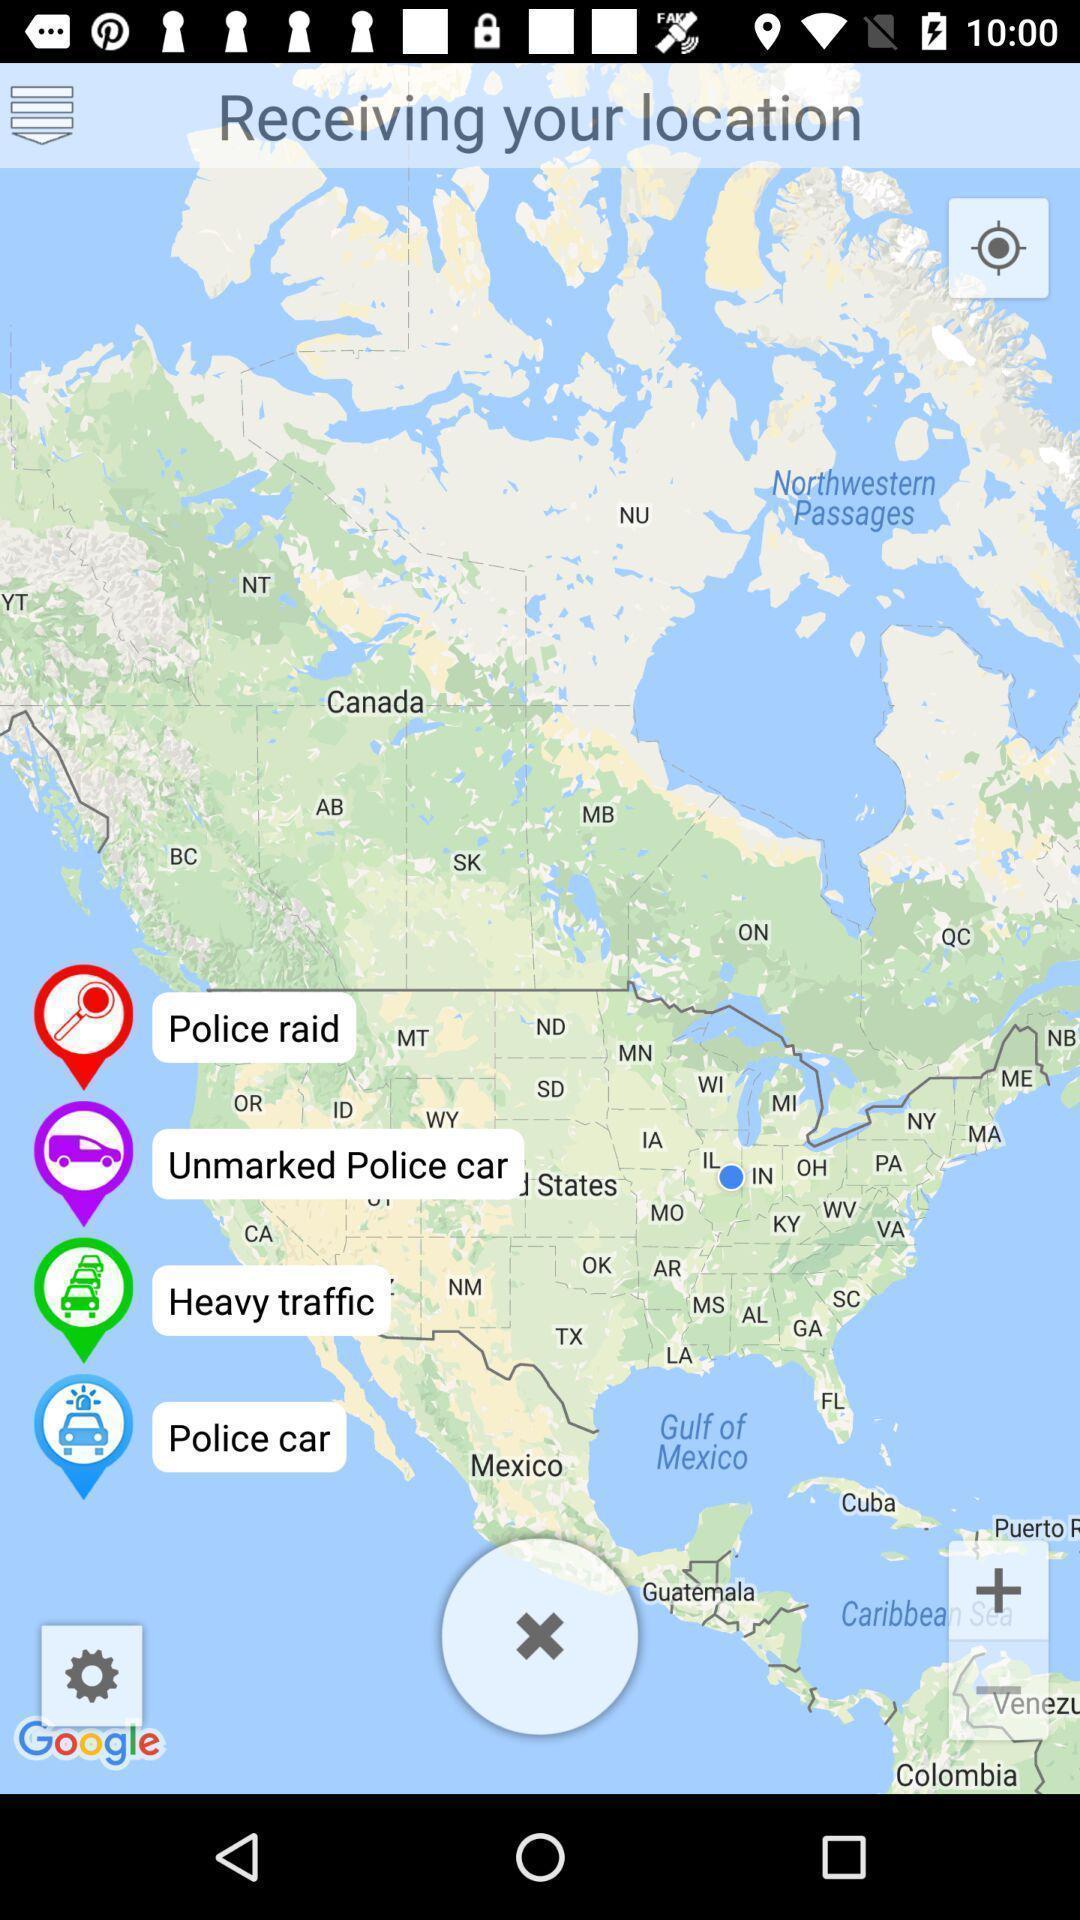Tell me about the visual elements in this screen capture. Screen page displaying map with different options. 